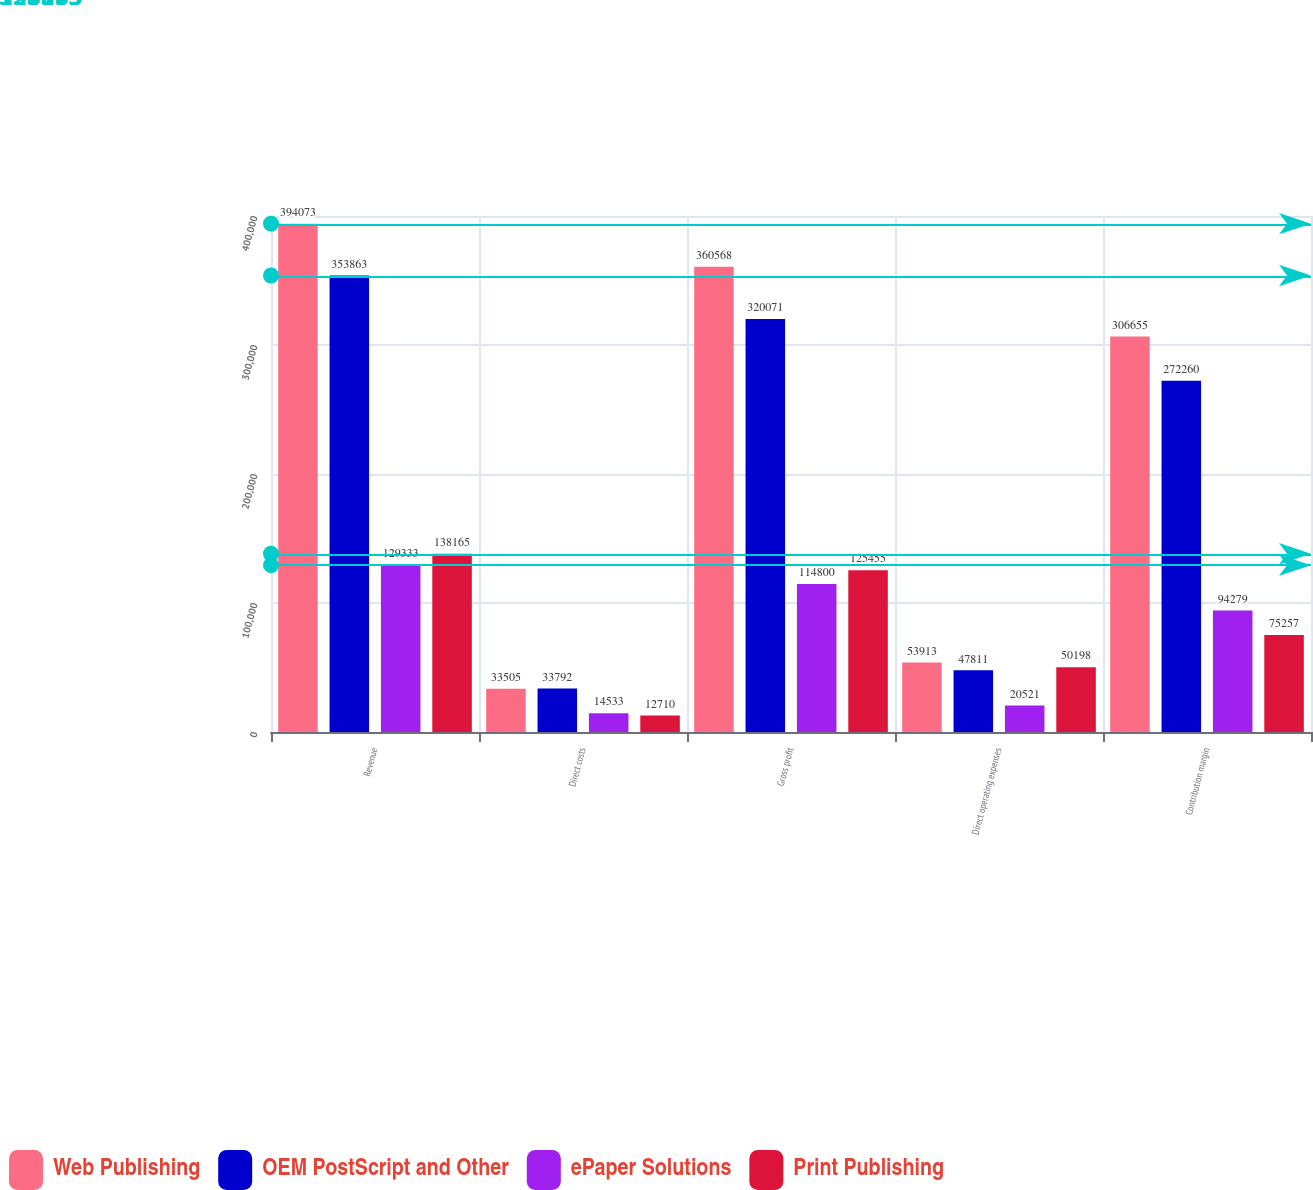<chart> <loc_0><loc_0><loc_500><loc_500><stacked_bar_chart><ecel><fcel>Revenue<fcel>Direct costs<fcel>Gross profit<fcel>Direct operating expenses<fcel>Contribution margin<nl><fcel>Web Publishing<fcel>394073<fcel>33505<fcel>360568<fcel>53913<fcel>306655<nl><fcel>OEM PostScript and Other<fcel>353863<fcel>33792<fcel>320071<fcel>47811<fcel>272260<nl><fcel>ePaper Solutions<fcel>129333<fcel>14533<fcel>114800<fcel>20521<fcel>94279<nl><fcel>Print Publishing<fcel>138165<fcel>12710<fcel>125455<fcel>50198<fcel>75257<nl></chart> 